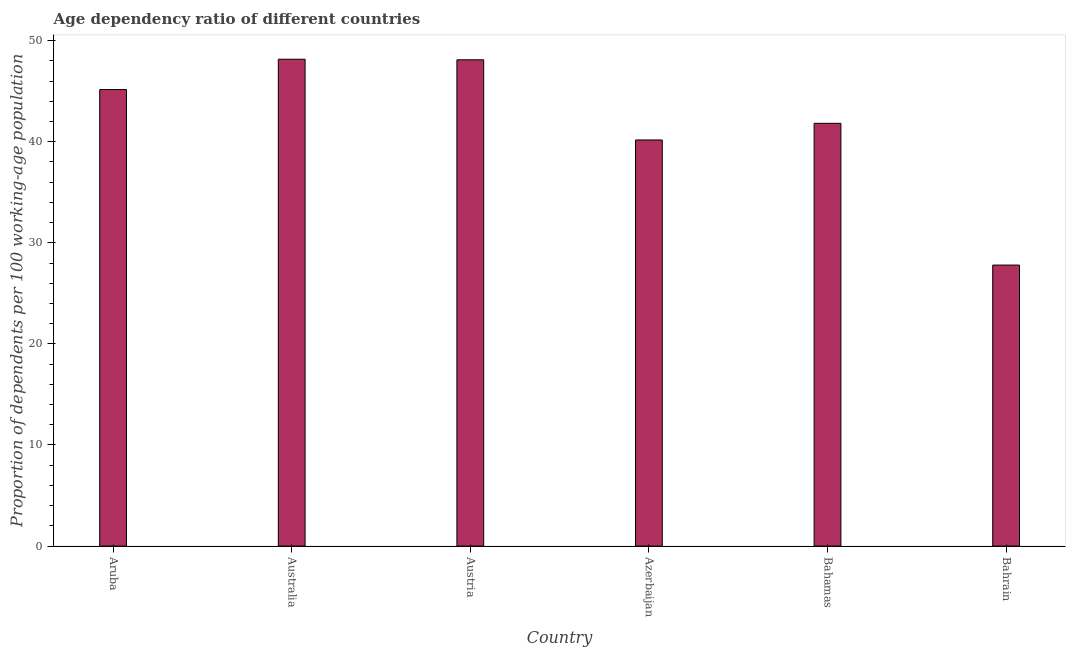Does the graph contain grids?
Make the answer very short. No. What is the title of the graph?
Your answer should be compact. Age dependency ratio of different countries. What is the label or title of the Y-axis?
Offer a terse response. Proportion of dependents per 100 working-age population. What is the age dependency ratio in Bahrain?
Your answer should be very brief. 27.8. Across all countries, what is the maximum age dependency ratio?
Provide a short and direct response. 48.16. Across all countries, what is the minimum age dependency ratio?
Give a very brief answer. 27.8. In which country was the age dependency ratio maximum?
Your answer should be compact. Australia. In which country was the age dependency ratio minimum?
Keep it short and to the point. Bahrain. What is the sum of the age dependency ratio?
Your answer should be very brief. 251.19. What is the difference between the age dependency ratio in Austria and Azerbaijan?
Your answer should be compact. 7.93. What is the average age dependency ratio per country?
Your answer should be compact. 41.87. What is the median age dependency ratio?
Give a very brief answer. 43.49. In how many countries, is the age dependency ratio greater than 20 ?
Keep it short and to the point. 6. What is the ratio of the age dependency ratio in Azerbaijan to that in Bahamas?
Your answer should be compact. 0.96. Is the age dependency ratio in Austria less than that in Azerbaijan?
Give a very brief answer. No. Is the difference between the age dependency ratio in Bahamas and Bahrain greater than the difference between any two countries?
Offer a very short reply. No. What is the difference between the highest and the second highest age dependency ratio?
Your response must be concise. 0.06. Is the sum of the age dependency ratio in Austria and Azerbaijan greater than the maximum age dependency ratio across all countries?
Your answer should be compact. Yes. What is the difference between the highest and the lowest age dependency ratio?
Give a very brief answer. 20.36. How many bars are there?
Your answer should be very brief. 6. How many countries are there in the graph?
Your response must be concise. 6. Are the values on the major ticks of Y-axis written in scientific E-notation?
Ensure brevity in your answer.  No. What is the Proportion of dependents per 100 working-age population in Aruba?
Keep it short and to the point. 45.16. What is the Proportion of dependents per 100 working-age population of Australia?
Your answer should be compact. 48.16. What is the Proportion of dependents per 100 working-age population of Austria?
Ensure brevity in your answer.  48.1. What is the Proportion of dependents per 100 working-age population in Azerbaijan?
Keep it short and to the point. 40.17. What is the Proportion of dependents per 100 working-age population of Bahamas?
Your answer should be very brief. 41.82. What is the Proportion of dependents per 100 working-age population in Bahrain?
Offer a terse response. 27.8. What is the difference between the Proportion of dependents per 100 working-age population in Aruba and Australia?
Give a very brief answer. -3. What is the difference between the Proportion of dependents per 100 working-age population in Aruba and Austria?
Offer a terse response. -2.94. What is the difference between the Proportion of dependents per 100 working-age population in Aruba and Azerbaijan?
Ensure brevity in your answer.  4.99. What is the difference between the Proportion of dependents per 100 working-age population in Aruba and Bahamas?
Provide a short and direct response. 3.34. What is the difference between the Proportion of dependents per 100 working-age population in Aruba and Bahrain?
Provide a succinct answer. 17.36. What is the difference between the Proportion of dependents per 100 working-age population in Australia and Austria?
Ensure brevity in your answer.  0.06. What is the difference between the Proportion of dependents per 100 working-age population in Australia and Azerbaijan?
Your answer should be compact. 7.99. What is the difference between the Proportion of dependents per 100 working-age population in Australia and Bahamas?
Offer a very short reply. 6.34. What is the difference between the Proportion of dependents per 100 working-age population in Australia and Bahrain?
Make the answer very short. 20.36. What is the difference between the Proportion of dependents per 100 working-age population in Austria and Azerbaijan?
Ensure brevity in your answer.  7.93. What is the difference between the Proportion of dependents per 100 working-age population in Austria and Bahamas?
Give a very brief answer. 6.28. What is the difference between the Proportion of dependents per 100 working-age population in Austria and Bahrain?
Provide a succinct answer. 20.3. What is the difference between the Proportion of dependents per 100 working-age population in Azerbaijan and Bahamas?
Offer a terse response. -1.65. What is the difference between the Proportion of dependents per 100 working-age population in Azerbaijan and Bahrain?
Offer a very short reply. 12.37. What is the difference between the Proportion of dependents per 100 working-age population in Bahamas and Bahrain?
Give a very brief answer. 14.02. What is the ratio of the Proportion of dependents per 100 working-age population in Aruba to that in Australia?
Ensure brevity in your answer.  0.94. What is the ratio of the Proportion of dependents per 100 working-age population in Aruba to that in Austria?
Keep it short and to the point. 0.94. What is the ratio of the Proportion of dependents per 100 working-age population in Aruba to that in Azerbaijan?
Your response must be concise. 1.12. What is the ratio of the Proportion of dependents per 100 working-age population in Aruba to that in Bahrain?
Offer a terse response. 1.62. What is the ratio of the Proportion of dependents per 100 working-age population in Australia to that in Austria?
Your answer should be very brief. 1. What is the ratio of the Proportion of dependents per 100 working-age population in Australia to that in Azerbaijan?
Offer a terse response. 1.2. What is the ratio of the Proportion of dependents per 100 working-age population in Australia to that in Bahamas?
Your answer should be very brief. 1.15. What is the ratio of the Proportion of dependents per 100 working-age population in Australia to that in Bahrain?
Provide a succinct answer. 1.73. What is the ratio of the Proportion of dependents per 100 working-age population in Austria to that in Azerbaijan?
Ensure brevity in your answer.  1.2. What is the ratio of the Proportion of dependents per 100 working-age population in Austria to that in Bahamas?
Provide a short and direct response. 1.15. What is the ratio of the Proportion of dependents per 100 working-age population in Austria to that in Bahrain?
Provide a short and direct response. 1.73. What is the ratio of the Proportion of dependents per 100 working-age population in Azerbaijan to that in Bahrain?
Provide a succinct answer. 1.45. What is the ratio of the Proportion of dependents per 100 working-age population in Bahamas to that in Bahrain?
Provide a succinct answer. 1.5. 